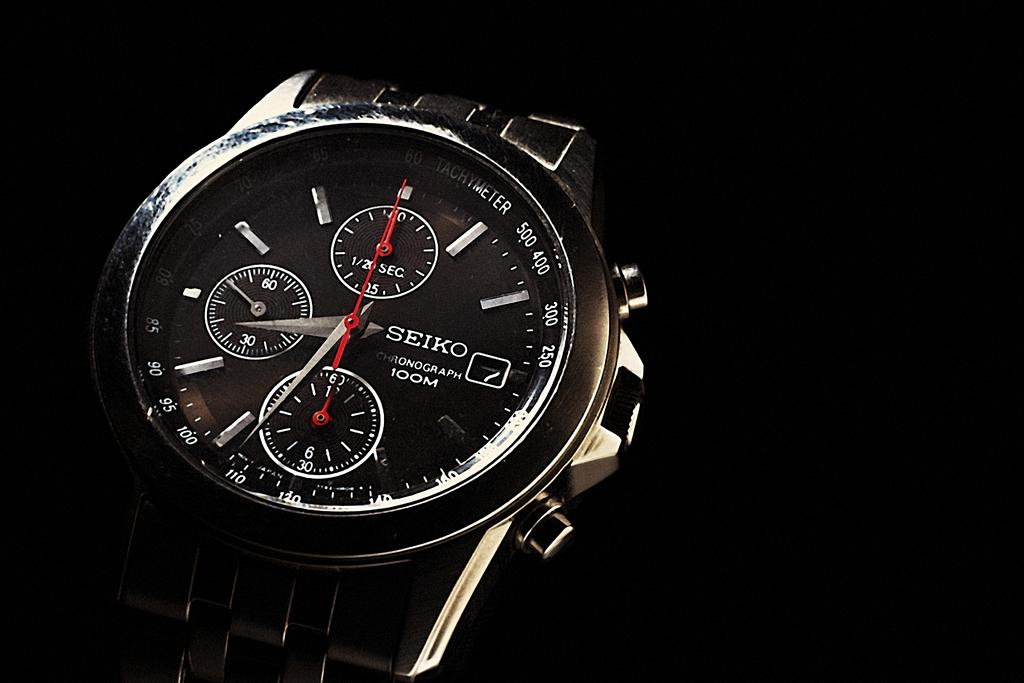<image>
Give a short and clear explanation of the subsequent image. a SEIKO watch face with barely any light on it 